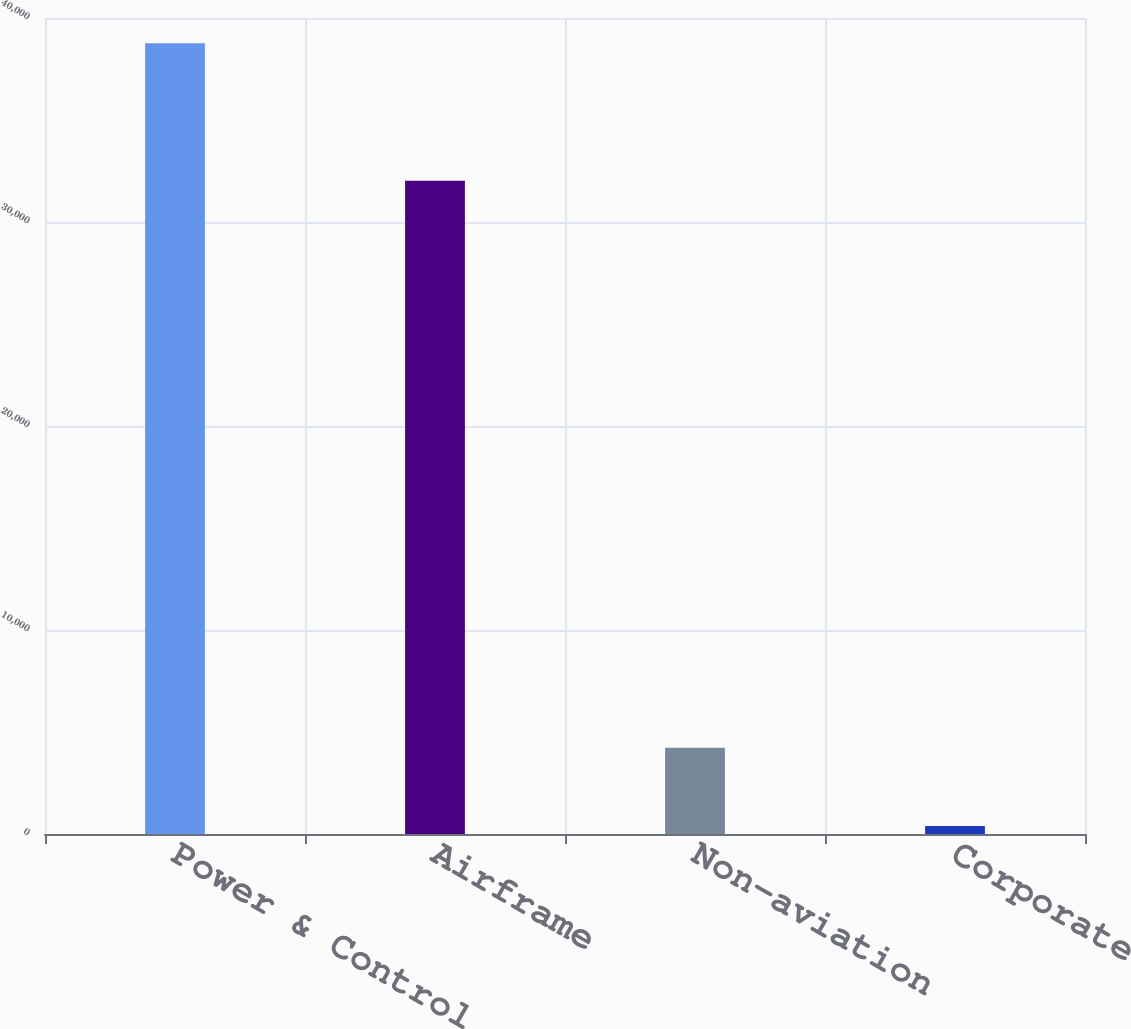<chart> <loc_0><loc_0><loc_500><loc_500><bar_chart><fcel>Power & Control<fcel>Airframe<fcel>Non-aviation<fcel>Corporate<nl><fcel>38762<fcel>32028<fcel>4231.7<fcel>395<nl></chart> 